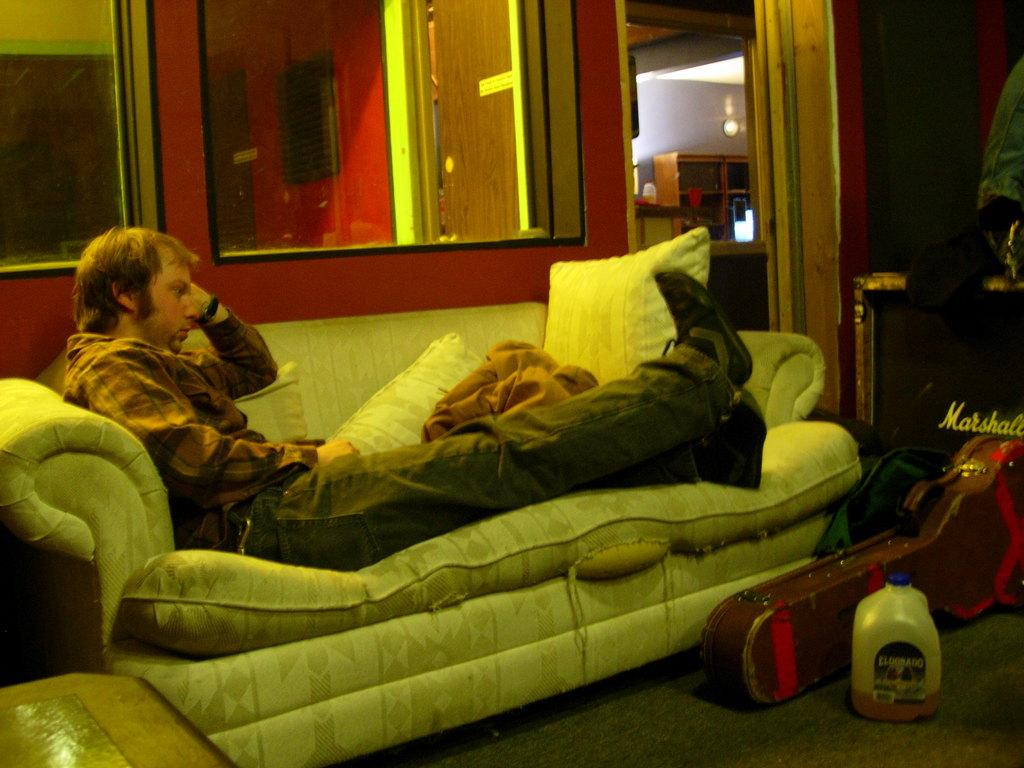What is the person in the image doing? There is a person sitting on the sofa. What can be seen on the sofa besides the person? There are pillows on the sofa. What is on the floor near the sofa? There is a bottle and a guitar bag on the floor. What can be seen in the background of the image? There is a window, a wall, and a mirror in the background. What invention is being demonstrated in the image? There is no invention being demonstrated in the image; it simply shows a person sitting on a sofa with various objects nearby. What scent can be detected in the image? There is no mention of any scent in the image, so it cannot be determined from the picture. 